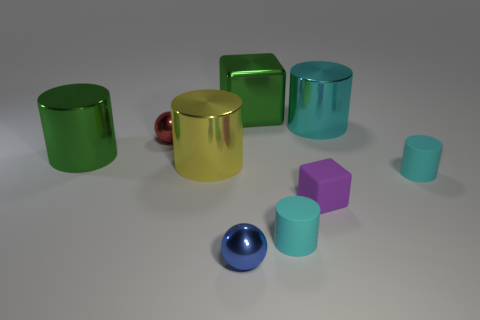There is a yellow thing that is made of the same material as the red sphere; what shape is it?
Keep it short and to the point. Cylinder. Are there fewer yellow objects right of the large metal cube than tiny red matte things?
Your response must be concise. No. The tiny thing that is left of the blue ball is what color?
Provide a succinct answer. Red. What material is the big object that is the same color as the metallic cube?
Your response must be concise. Metal. Are there any other large metal objects of the same shape as the yellow thing?
Ensure brevity in your answer.  Yes. What number of other objects have the same shape as the purple matte object?
Provide a short and direct response. 1. Is the color of the small rubber block the same as the large shiny cube?
Offer a very short reply. No. Is the number of gray shiny cylinders less than the number of purple cubes?
Make the answer very short. Yes. What material is the cylinder that is on the left side of the red shiny thing?
Your answer should be compact. Metal. There is a purple block that is the same size as the blue metallic sphere; what material is it?
Offer a very short reply. Rubber. 